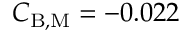<formula> <loc_0><loc_0><loc_500><loc_500>C _ { B , M } = - 0 . 0 2 2</formula> 